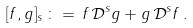Convert formula to latex. <formula><loc_0><loc_0><loc_500><loc_500>[ f , g ] _ { s } \, \colon = \, f \, \mathcal { D } ^ { s } g + g \, \mathcal { D } ^ { s } f \, .</formula> 